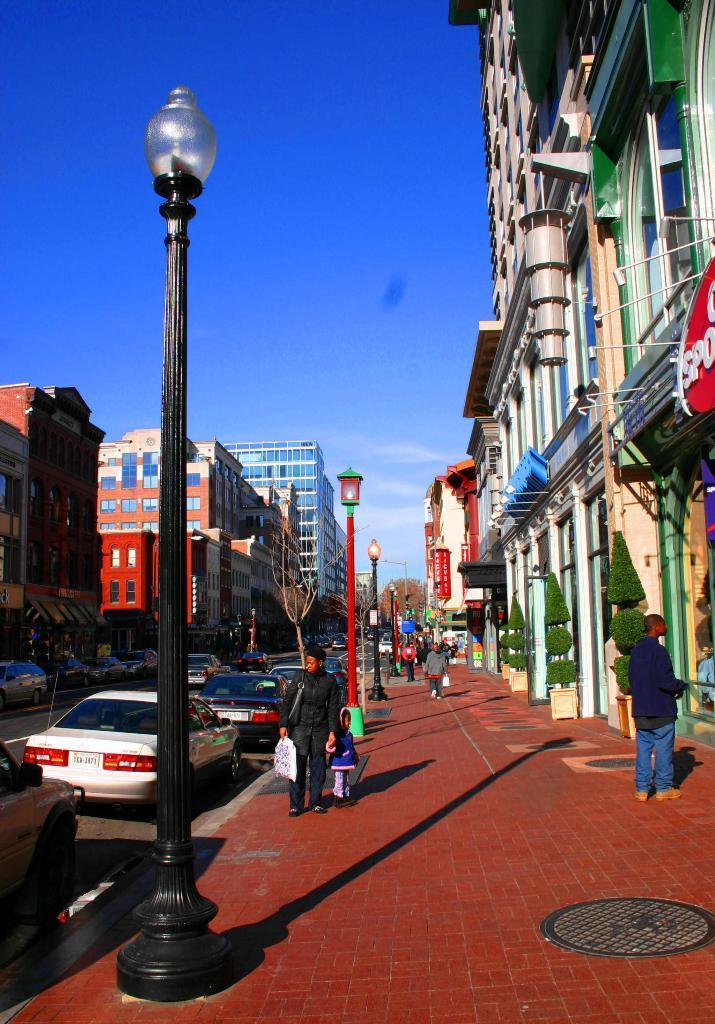Can you describe this image briefly? This is the picture of a city. In this image there are group of people on the footpath and there are vehicles on the road. There are buildings and trees and there are poles and there is a manhole on the footpath. At the top there is sky and there are clouds. At the bottom there is a road. 